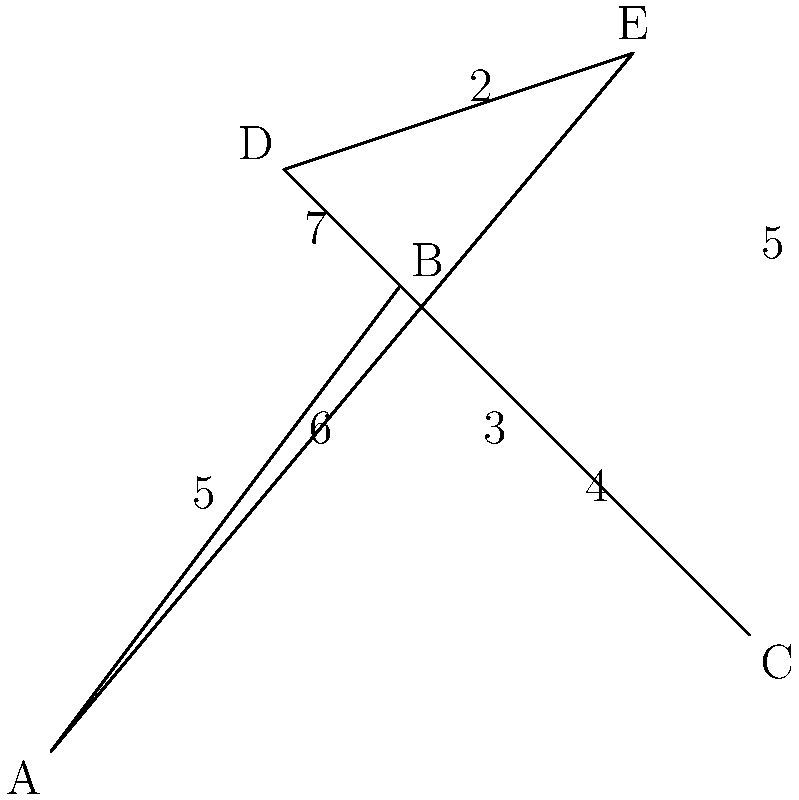You need to make deliveries to all five locations (A, B, C, D, and E) shown on the map, starting and ending at point A. What is the shortest possible route that visits all locations exactly once before returning to A, and what is its total distance? To find the shortest route, we need to consider all possible permutations of visiting the points B, C, D, and E, always starting and ending at A. This is known as the Traveling Salesman Problem.

Let's examine the possible routes:

1. A-B-C-D-E-A: 5 + 4 + 3 + 2 + 6 = 20
2. A-B-C-E-D-A: 5 + 4 + 5 + 2 + 6 = 22
3. A-B-D-C-E-A: 5 + 7 + 3 + 5 + 6 = 26
4. A-B-D-E-C-A: 5 + 7 + 2 + 5 + 4 = 23
5. A-B-E-C-D-A: 5 + 7 + 5 + 3 + 6 = 26
6. A-B-E-D-C-A: 5 + 7 + 2 + 3 + 4 = 21
7. A-C-B-D-E-A: 6 + 4 + 7 + 2 + 6 = 25
8. A-C-B-E-D-A: 6 + 4 + 7 + 2 + 6 = 25
9. A-C-D-B-E-A: 6 + 3 + 7 + 7 + 6 = 29
10. A-C-D-E-B-A: 6 + 3 + 2 + 7 + 5 = 23
11. A-C-E-B-D-A: 6 + 5 + 7 + 7 + 6 = 31
12. A-C-E-D-B-A: 6 + 5 + 2 + 7 + 5 = 25

The shortest route is A-B-C-D-E-A with a total distance of 20 units.
Answer: A-B-C-D-E-A, 20 units 